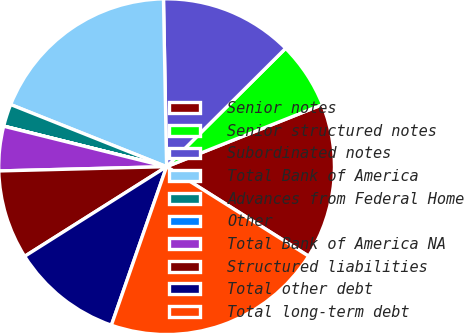Convert chart. <chart><loc_0><loc_0><loc_500><loc_500><pie_chart><fcel>Senior notes<fcel>Senior structured notes<fcel>Subordinated notes<fcel>Total Bank of America<fcel>Advances from Federal Home<fcel>Other<fcel>Total Bank of America NA<fcel>Structured liabilities<fcel>Total other debt<fcel>Total long-term debt<nl><fcel>14.98%<fcel>6.42%<fcel>12.84%<fcel>18.67%<fcel>2.15%<fcel>0.01%<fcel>4.28%<fcel>8.56%<fcel>10.7%<fcel>21.39%<nl></chart> 